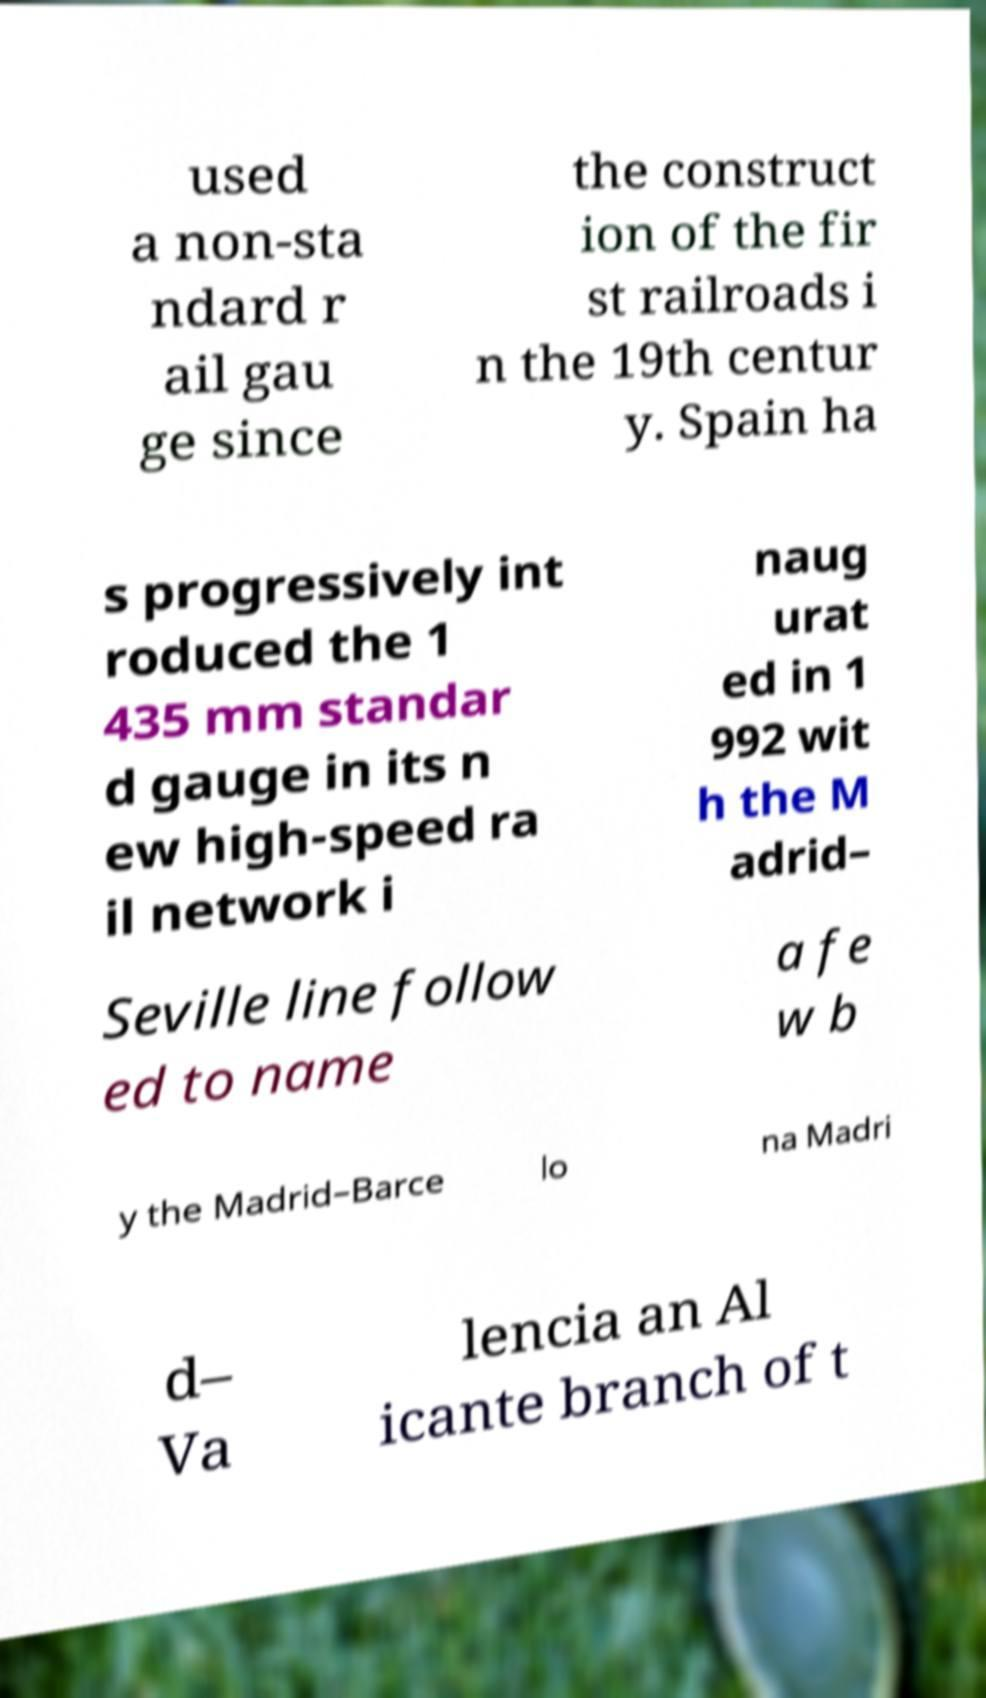Please read and relay the text visible in this image. What does it say? used a non-sta ndard r ail gau ge since the construct ion of the fir st railroads i n the 19th centur y. Spain ha s progressively int roduced the 1 435 mm standar d gauge in its n ew high-speed ra il network i naug urat ed in 1 992 wit h the M adrid– Seville line follow ed to name a fe w b y the Madrid–Barce lo na Madri d– Va lencia an Al icante branch of t 